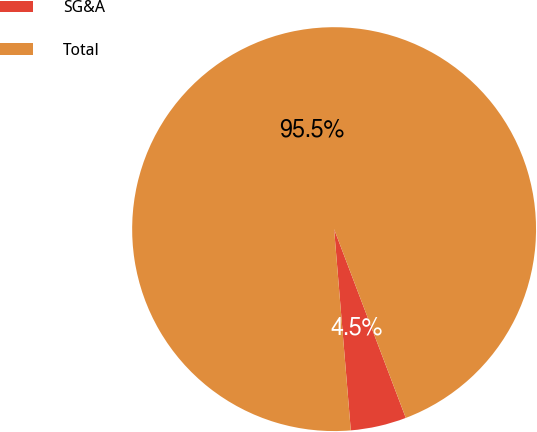<chart> <loc_0><loc_0><loc_500><loc_500><pie_chart><fcel>SG&A<fcel>Total<nl><fcel>4.46%<fcel>95.54%<nl></chart> 